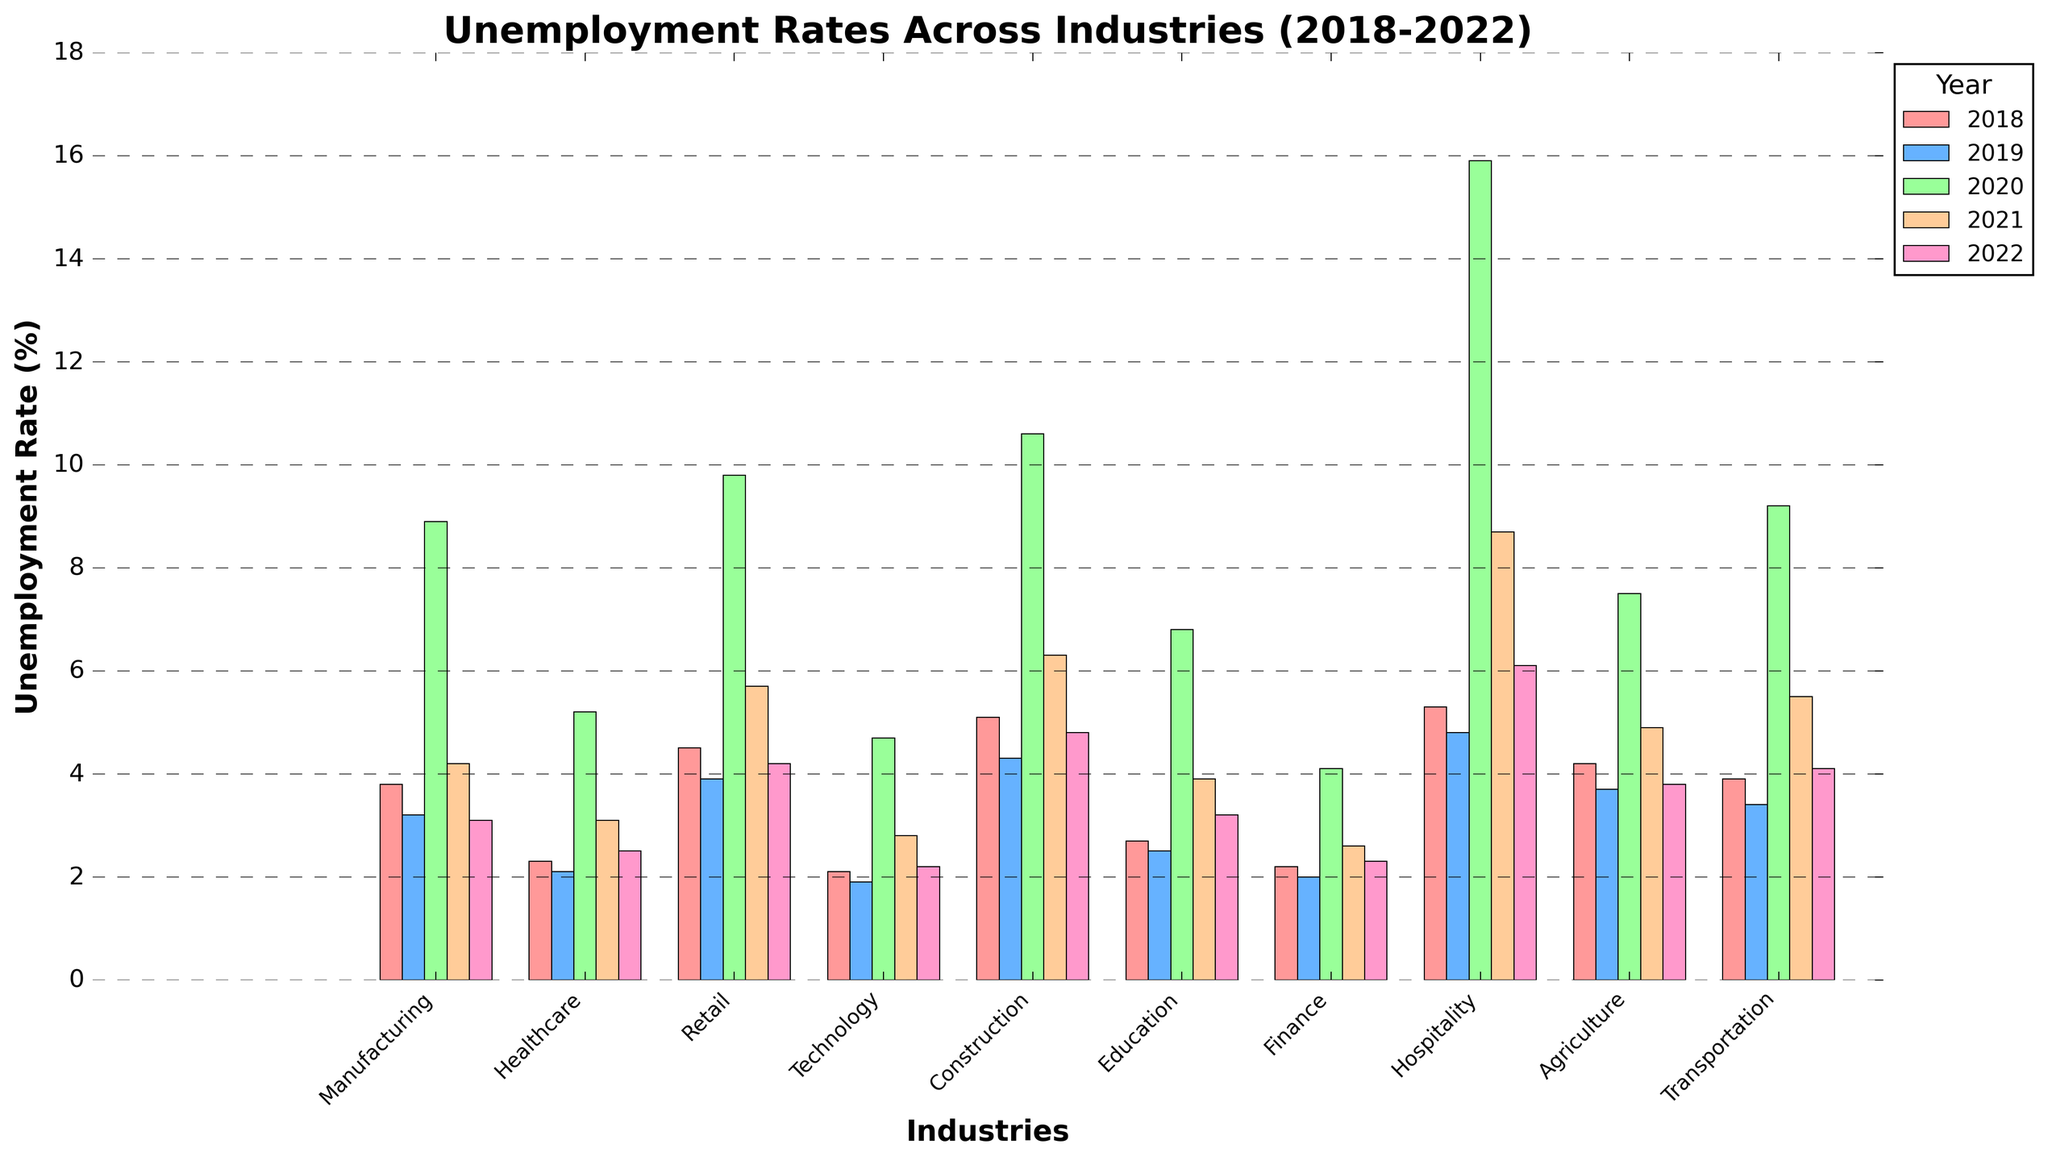What industry had the highest unemployment rate in 2020? Look up the bars corresponding to 2020. The tallest bar representing unemployment in 2020 is for the Hospitality industry.
Answer: Hospitality Which industry showed the most significant decrease in unemployment rate from 2020 to 2022? Compare the height of the bars for each industry from 2020 to 2022. The Hospitality industry saw the largest drop in the height of the bar, from 15.9% to 6.1%.
Answer: Hospitality What were the unemployment rates in the Technology industry for the years 2018 and 2021? Identify the bars for the Technology industry. The bars' heights for 2018 and 2021 reflect unemployment rates of 2.1% and 2.8%, respectively.
Answer: 2.1%, 2.8% How did the unemployment rates in Construction fare through 2018-2022? Locate the bars for Construction from 2018 to 2022, and note their heights: 5.1%, 4.3%, 10.6%, 6.3%, 4.8%.
Answer: 5.1%, 4.3%, 10.6%, 6.3%, 4.8% Compare the average unemployment rate for the retail industry across the years 2018-2022 with that of agriculture. Which is higher? Calculate the average for Retail: (4.5+3.9+9.8+5.7+4.2)/5 = 5.62%. For Agriculture: (4.2+3.7+7.5+4.9+3.8)/5 = 4.82%. Retail has a higher average unemployment rate.
Answer: Retail Which year had the overall highest unemployment rates across all industries? Examine all years' bars and identify the year with the tallest bars across the board, which is 2020.
Answer: 2020 What is the visual difference between the unemployment rates in Healthcare and Finance for 2022? Compare the bar heights for Healthcare and Finance in 2022. The Healthcare bar is slightly taller than the Finance bar, indicating higher unemployment.
Answer: Healthcare is higher Compare the unemployment rates between Manufacturing and Education in 2021. Which is lower? Locate the bars for Manufacturing and Education in 2021. The Manufacturing bar is at 4.2%, whereas Education is at 3.9%. Education is lower.
Answer: Education What was the trend in unemployment rates for the Agriculture industry from 2018 to 2022? Track the bar heights for the Agriculture industry across 2018-2022: 4.2%, 3.7%, 7.5%, 4.9%, 3.8%. The rates show a rise in 2020 and a decrease afterward.
Answer: Rising in 2020, then decreasing 